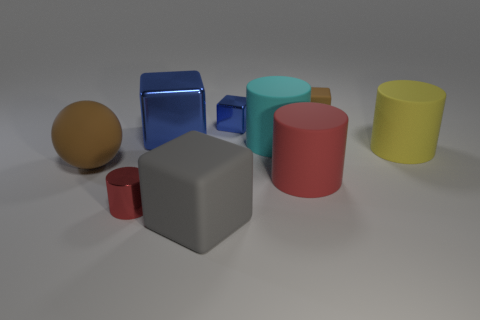Subtract all brown blocks. How many blocks are left? 3 Subtract all brown cubes. How many cubes are left? 3 Subtract all green cubes. How many red cylinders are left? 2 Add 1 big cyan cylinders. How many objects exist? 10 Subtract all blocks. How many objects are left? 5 Subtract 3 cylinders. How many cylinders are left? 1 Add 2 large gray matte things. How many large gray matte things are left? 3 Add 4 large matte blocks. How many large matte blocks exist? 5 Subtract 0 gray cylinders. How many objects are left? 9 Subtract all blue cylinders. Subtract all purple blocks. How many cylinders are left? 4 